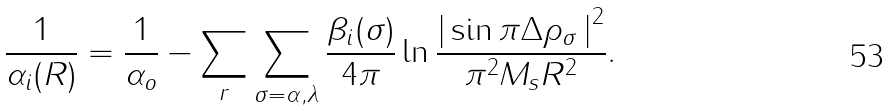<formula> <loc_0><loc_0><loc_500><loc_500>\frac { 1 } { \alpha _ { i } ( R ) } = \frac { 1 } { \alpha _ { o } } - \sum _ { r } \sum _ { \sigma = \alpha , \lambda } \frac { \beta _ { i } ( \sigma ) } { 4 \pi } \ln \frac { \left | \, \sin \pi \Delta \rho _ { \sigma } \, \right | ^ { 2 } } { \pi ^ { 2 } M _ { s } R ^ { 2 } } .</formula> 